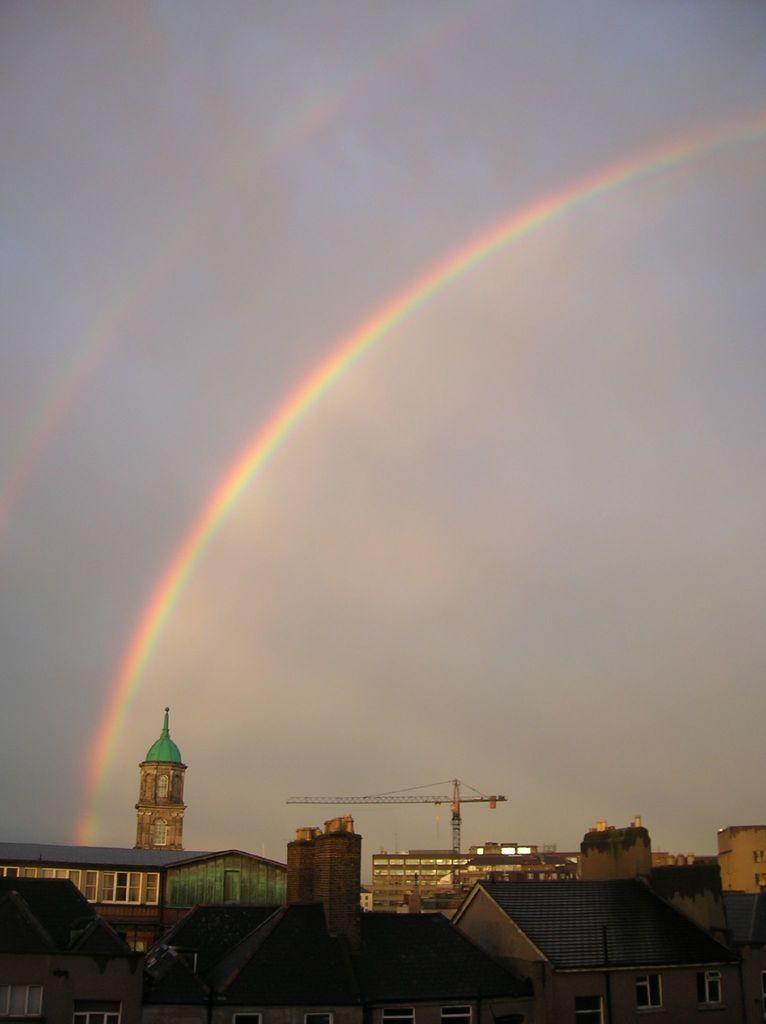Please provide a concise description of this image. This image consists of houses. In the background, we can see a crane. At the top, there is a rainbow in the sky. 